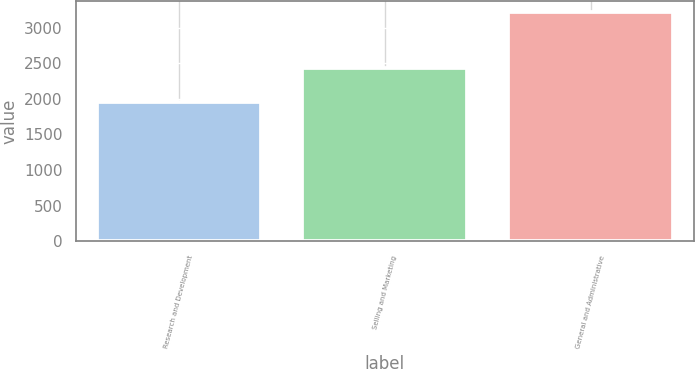<chart> <loc_0><loc_0><loc_500><loc_500><bar_chart><fcel>Research and Development<fcel>Selling and Marketing<fcel>General and Administrative<nl><fcel>1958<fcel>2438<fcel>3215<nl></chart> 